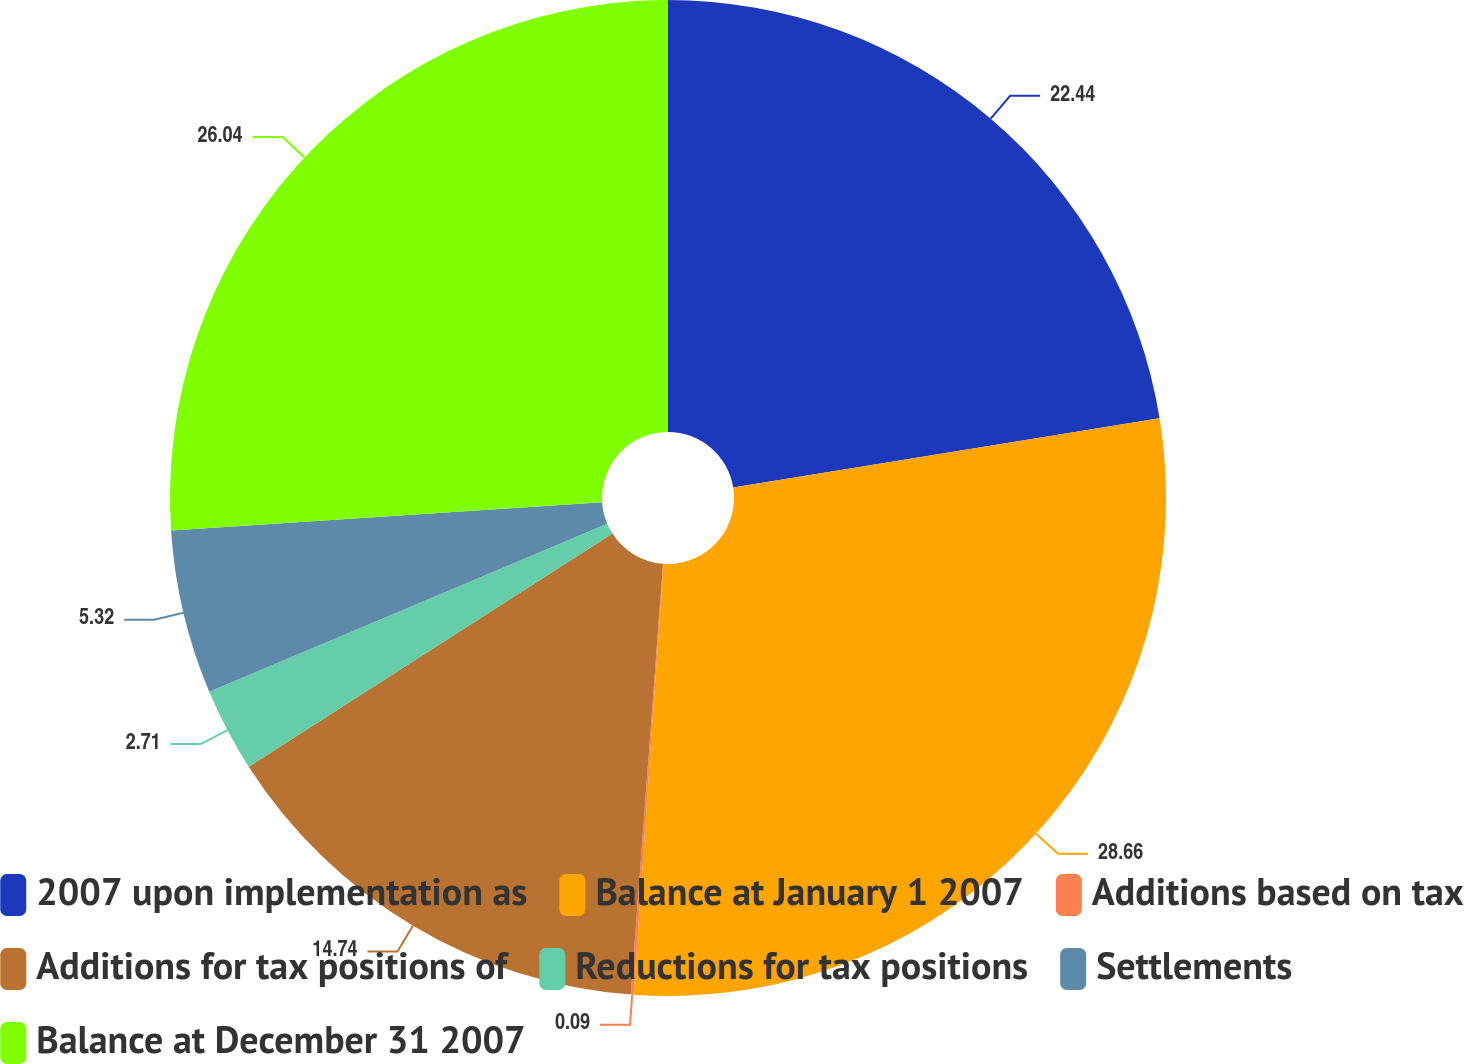<chart> <loc_0><loc_0><loc_500><loc_500><pie_chart><fcel>2007 upon implementation as<fcel>Balance at January 1 2007<fcel>Additions based on tax<fcel>Additions for tax positions of<fcel>Reductions for tax positions<fcel>Settlements<fcel>Balance at December 31 2007<nl><fcel>22.44%<fcel>28.66%<fcel>0.09%<fcel>14.74%<fcel>2.71%<fcel>5.32%<fcel>26.04%<nl></chart> 